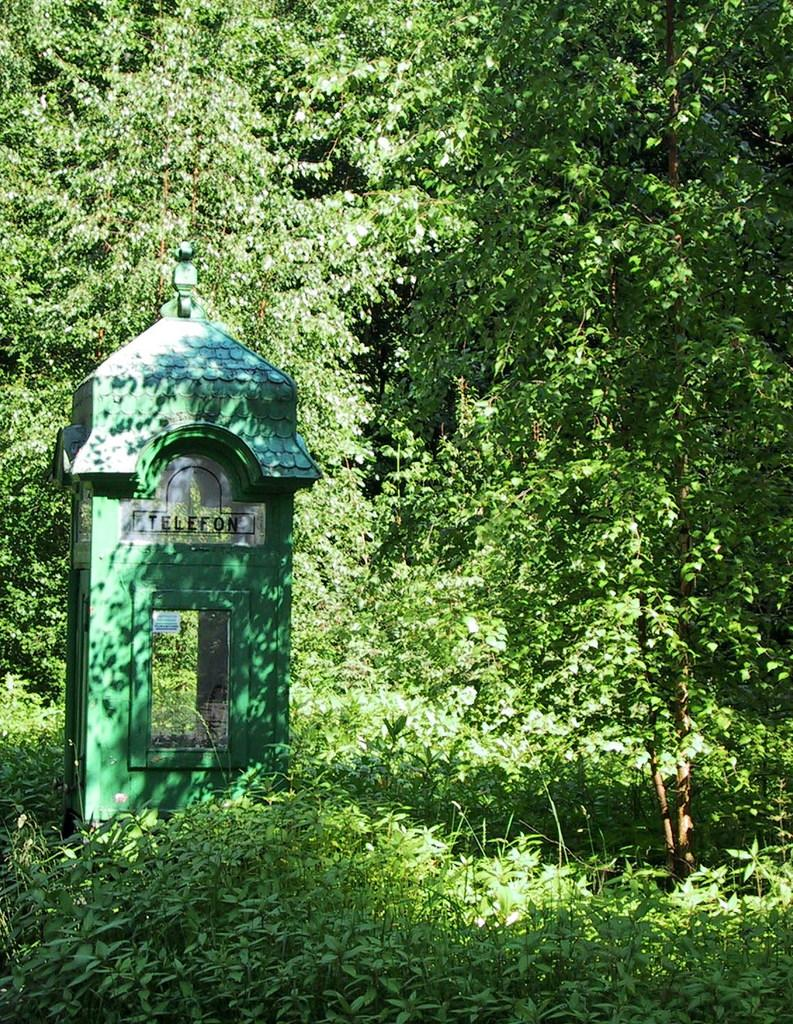What type of natural elements are present in the image? There are many trees and plants in the image. What man-made structure can be seen on the left side of the image? There is a telephone booth on the left side of the image. What type of container is visible in the image? There is a glass in the image. What type of decorative item is present in the image? There is a sticker in the image. What type of cracker is being used to hold up the sticker in the image? There is no cracker present in the image, and the sticker is not being held up by any cracker. 